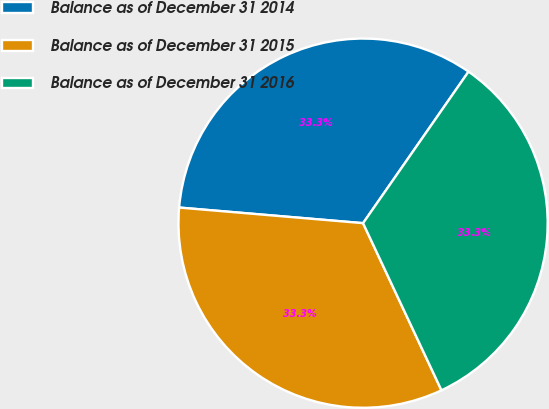Convert chart. <chart><loc_0><loc_0><loc_500><loc_500><pie_chart><fcel>Balance as of December 31 2014<fcel>Balance as of December 31 2015<fcel>Balance as of December 31 2016<nl><fcel>33.33%<fcel>33.33%<fcel>33.34%<nl></chart> 